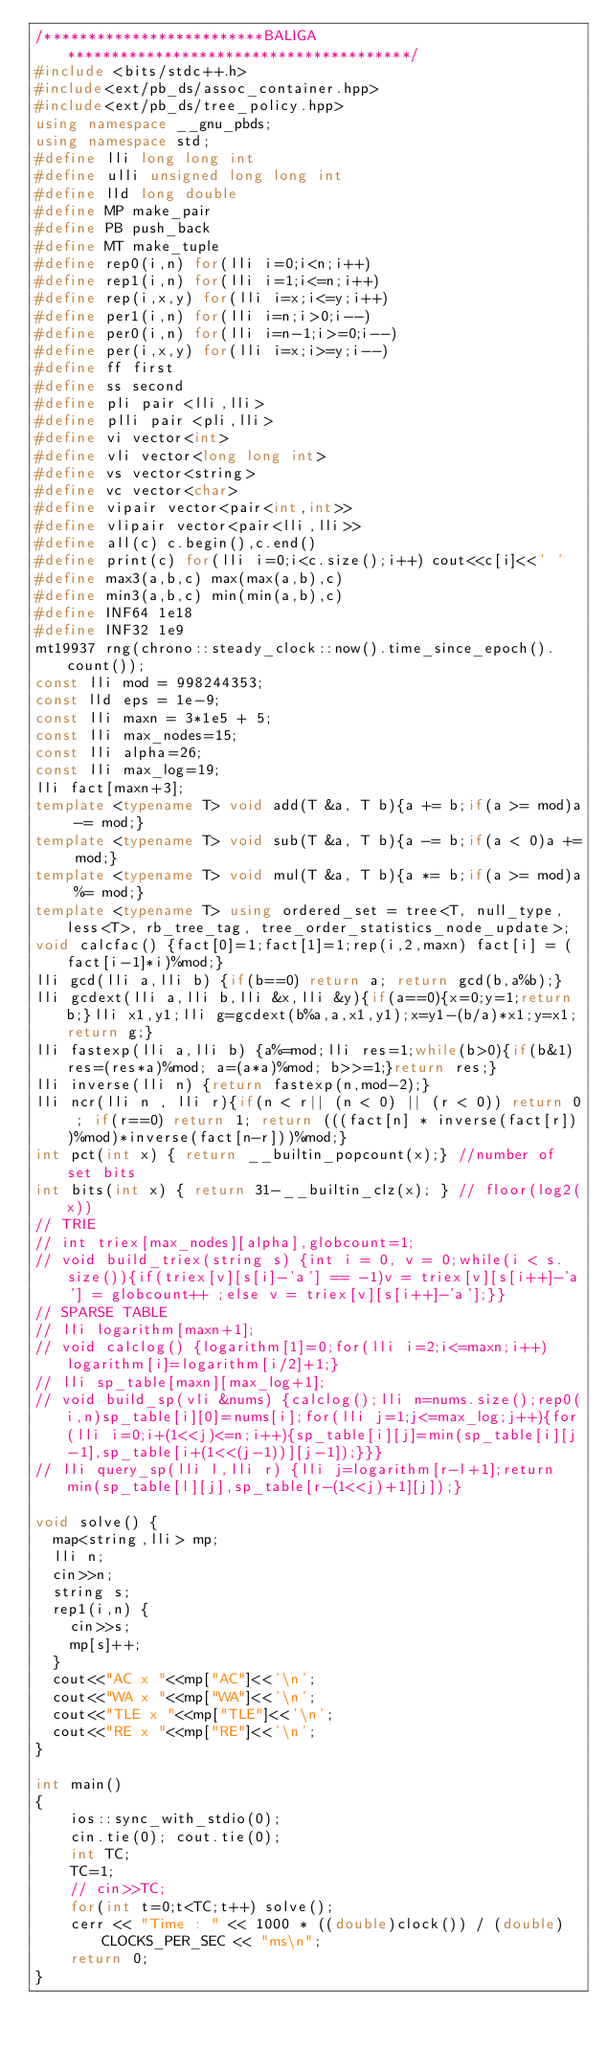Convert code to text. <code><loc_0><loc_0><loc_500><loc_500><_C++_>/*************************BALIGA***************************************/
#include <bits/stdc++.h>
#include<ext/pb_ds/assoc_container.hpp>
#include<ext/pb_ds/tree_policy.hpp>
using namespace __gnu_pbds;
using namespace std;
#define lli long long int
#define ulli unsigned long long int
#define lld long double
#define MP make_pair
#define PB push_back
#define MT make_tuple
#define rep0(i,n) for(lli i=0;i<n;i++)
#define rep1(i,n) for(lli i=1;i<=n;i++)
#define rep(i,x,y) for(lli i=x;i<=y;i++)
#define per1(i,n) for(lli i=n;i>0;i--)
#define per0(i,n) for(lli i=n-1;i>=0;i--)
#define per(i,x,y) for(lli i=x;i>=y;i--)
#define ff first
#define ss second
#define pli pair <lli,lli>
#define plli pair <pli,lli>
#define vi vector<int>
#define vli vector<long long int>
#define vs vector<string>
#define vc vector<char>
#define vipair vector<pair<int,int>>
#define vlipair vector<pair<lli,lli>>
#define all(c) c.begin(),c.end()
#define print(c) for(lli i=0;i<c.size();i++) cout<<c[i]<<' '
#define max3(a,b,c) max(max(a,b),c)
#define min3(a,b,c) min(min(a,b),c)
#define INF64 1e18
#define INF32 1e9
mt19937 rng(chrono::steady_clock::now().time_since_epoch().count());
const lli mod = 998244353;
const lld eps = 1e-9;
const lli maxn = 3*1e5 + 5;
const lli max_nodes=15;
const lli alpha=26;
const lli max_log=19;
lli fact[maxn+3];
template <typename T> void add(T &a, T b){a += b;if(a >= mod)a -= mod;}
template <typename T> void sub(T &a, T b){a -= b;if(a < 0)a += mod;}
template <typename T> void mul(T &a, T b){a *= b;if(a >= mod)a %= mod;}
template <typename T> using ordered_set = tree<T, null_type, less<T>, rb_tree_tag, tree_order_statistics_node_update>;
void calcfac() {fact[0]=1;fact[1]=1;rep(i,2,maxn) fact[i] = (fact[i-1]*i)%mod;}
lli gcd(lli a,lli b) {if(b==0) return a; return gcd(b,a%b);}
lli gcdext(lli a,lli b,lli &x,lli &y){if(a==0){x=0;y=1;return b;}lli x1,y1;lli g=gcdext(b%a,a,x1,y1);x=y1-(b/a)*x1;y=x1;return g;}
lli fastexp(lli a,lli b) {a%=mod;lli res=1;while(b>0){if(b&1) res=(res*a)%mod; a=(a*a)%mod; b>>=1;}return res;}
lli inverse(lli n) {return fastexp(n,mod-2);}
lli ncr(lli n , lli r){if(n < r|| (n < 0) || (r < 0)) return 0 ; if(r==0) return 1; return (((fact[n] * inverse(fact[r]))%mod)*inverse(fact[n-r]))%mod;}
int pct(int x) { return __builtin_popcount(x);} //number of set bits 
int bits(int x) { return 31-__builtin_clz(x); } // floor(log2(x)) 
// TRIE
// int triex[max_nodes][alpha],globcount=1;
// void build_triex(string s) {int i = 0, v = 0;while(i < s.size()){if(triex[v][s[i]-'a'] == -1)v = triex[v][s[i++]-'a'] = globcount++ ;else v = triex[v][s[i++]-'a'];}}
// SPARSE TABLE
// lli logarithm[maxn+1];
// void calclog() {logarithm[1]=0;for(lli i=2;i<=maxn;i++)logarithm[i]=logarithm[i/2]+1;}
// lli sp_table[maxn][max_log+1];
// void build_sp(vli &nums) {calclog();lli n=nums.size();rep0(i,n)sp_table[i][0]=nums[i];for(lli j=1;j<=max_log;j++){for(lli i=0;i+(1<<j)<=n;i++){sp_table[i][j]=min(sp_table[i][j-1],sp_table[i+(1<<(j-1))][j-1]);}}}
// lli query_sp(lli l,lli r) {lli j=logarithm[r-l+1];return min(sp_table[l][j],sp_table[r-(1<<j)+1][j]);}

void solve() {
	map<string,lli> mp;
	lli n;
	cin>>n;
	string s;
	rep1(i,n) {
		cin>>s;
		mp[s]++;
	}
	cout<<"AC x "<<mp["AC"]<<'\n';
	cout<<"WA x "<<mp["WA"]<<'\n';
	cout<<"TLE x "<<mp["TLE"]<<'\n';
	cout<<"RE x "<<mp["RE"]<<'\n';
} 
    
int main()
{
    ios::sync_with_stdio(0);
    cin.tie(0); cout.tie(0);
    int TC;
    TC=1;
    // cin>>TC;
    for(int t=0;t<TC;t++) solve();
    cerr << "Time : " << 1000 * ((double)clock()) / (double)CLOCKS_PER_SEC << "ms\n";
    return 0;
}</code> 